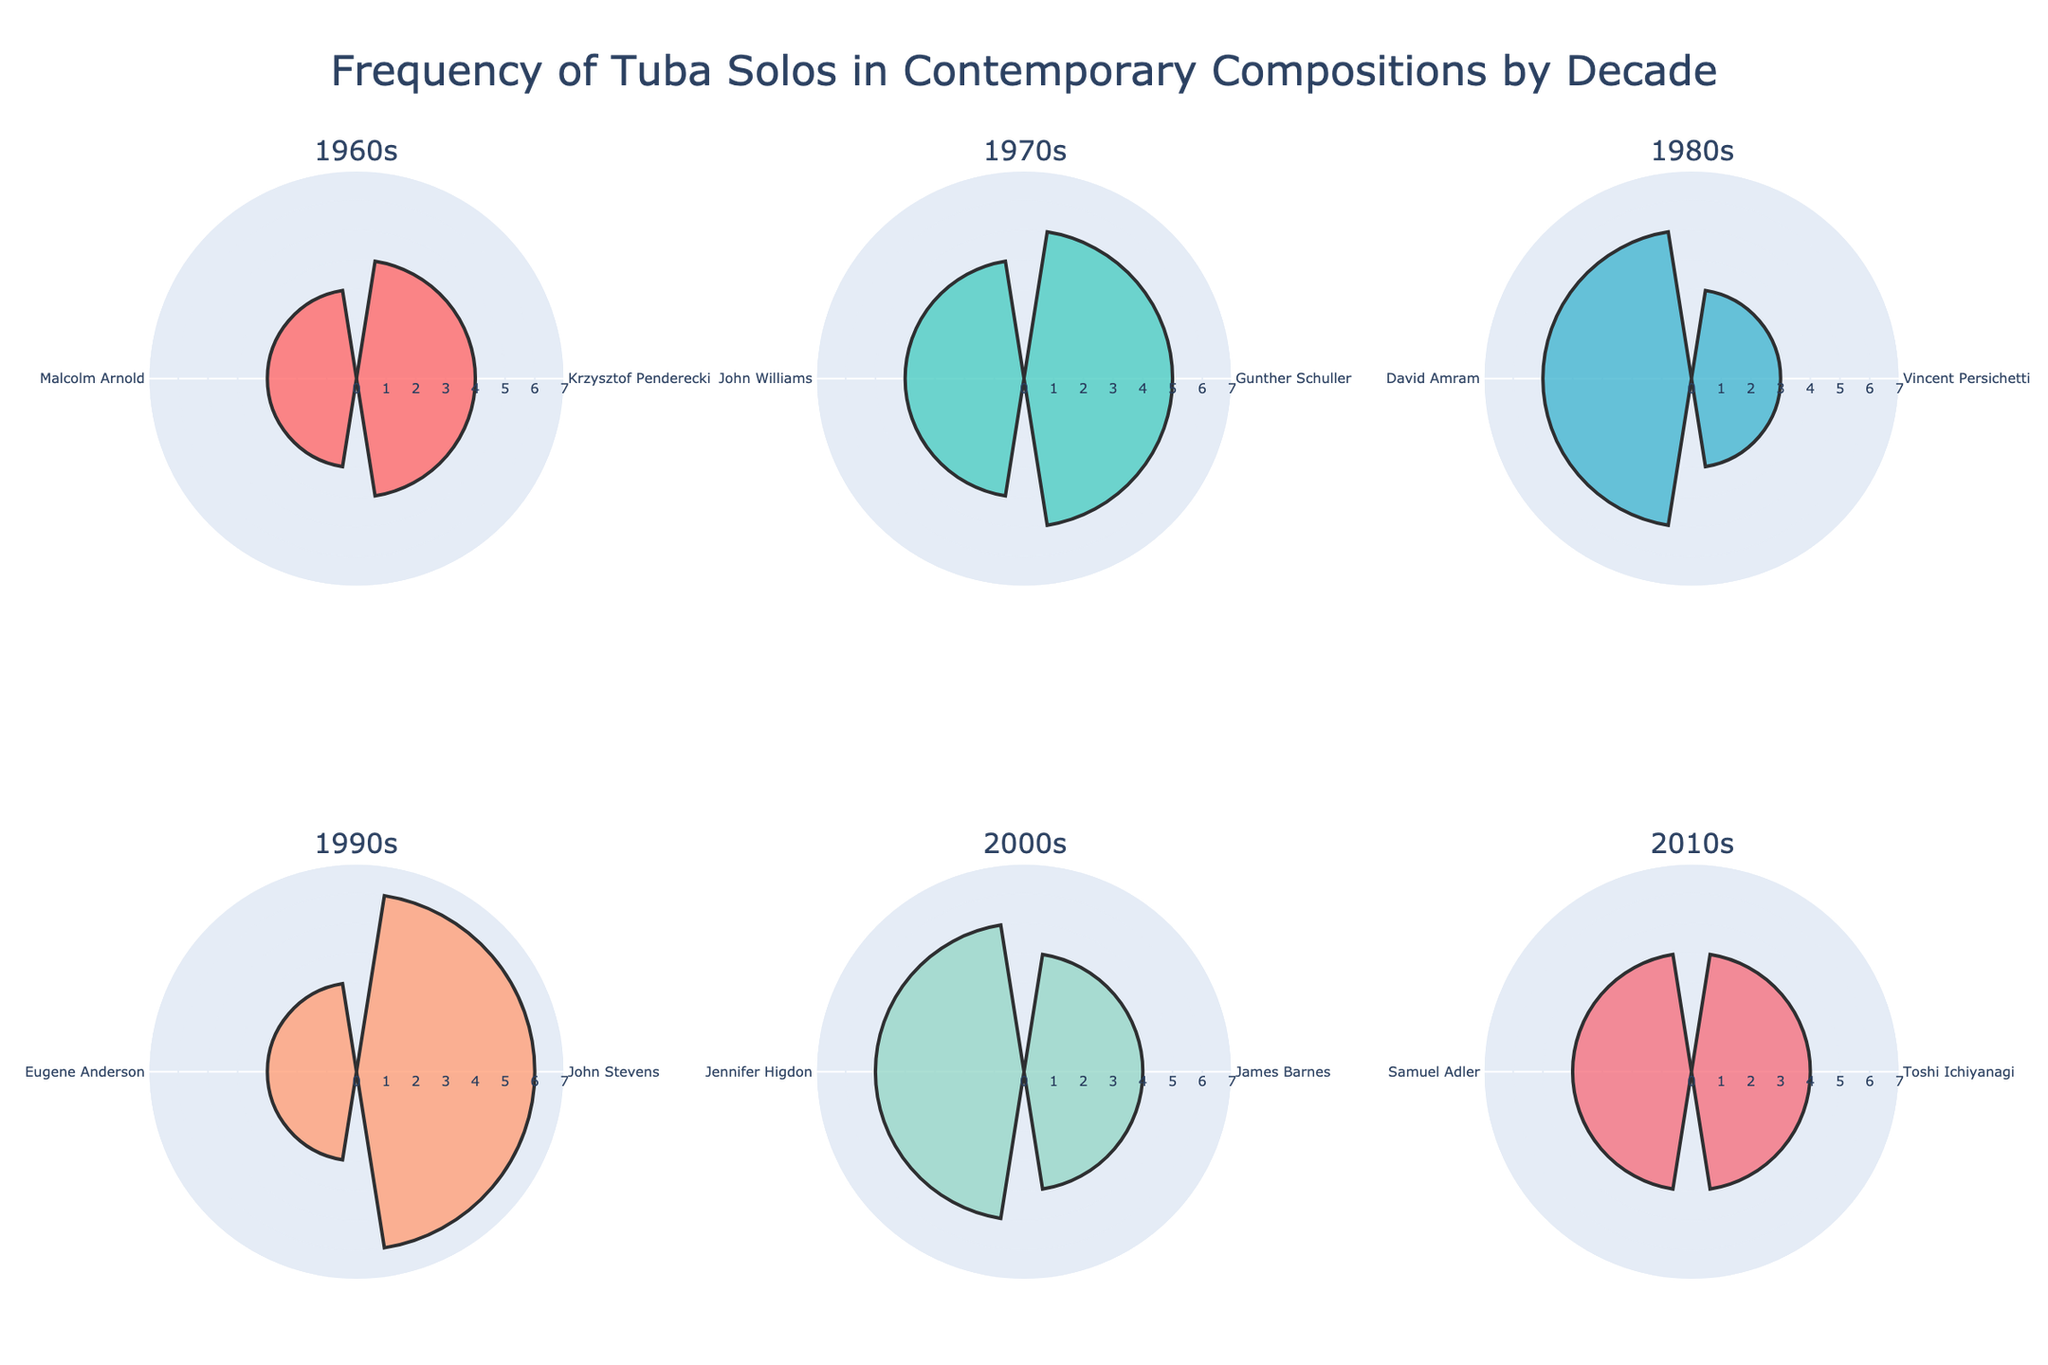What is the title of the figure? The title is usually displayed at the top of the figure. In this case, the title is bold and centered.
Answer: Frequency of Tuba Solos in Contemporary Compositions by Decade Which decade has the highest frequency of tuba solos in one composition? Look at all the degrees in each subplot and identify which subplot has the highest degree value on one of its polar radial bars. The 1990s have a radial value of 6 for John Stevens' "Journey," the highest in all subplots.
Answer: 1990s How many composers are featured in the 1980s subplot? Count the number of distinct sections (theta) in the 1980s subplot. The 1980s subplot has slices for Vincent Persichetti and David Amram, making it a total of two composers.
Answer: 2 What is the average number of tuba solos per composition in the 2000s? Add the number of tuba solos from all compositions in the 2000s and divide by the number of compositions. For the 2000s: (4 + 5) / 2 = 4.5.
Answer: 4.5 Which color is used to represent the 1960s in the chart? Identify the color associated with the 1960s subplot by looking at the visualizations for this decade. The rose chart for the 1960s uses a red shade.
Answer: Red Which decade has the most diverse range of compositions based on the number of tuba solos? Determine which decade has compositions with the most variability in the number of solos. The 1990s range from 3 (Eugene Anderson) to 6 (John Stevens).
Answer: 1990s Compare the number of tuba solos between the 1970s and the 2010s. Which decade has a higher cumulative total? Add the number of tuba solos for all compositions in each decade and compare the totals. For the 1970s: 5 (Gunther Schuller) + 4 (John Williams) = 9. For the 2010s: 4 (Toshi Ichiyanagi) + 4 (Samuel Adler) = 8. Therefore, the 1970s have a higher total.
Answer: 1970s What is the total number of tuba solos in the chart? Sum the number of tuba solos from all the compositions across all decades. 4 + 3 + 5 + 4 + 3 + 5 + 6 + 3 + 4 + 5 + 4 + 4 = 50.
Answer: 50 Which composition in the chart has the least number of tuba solos and in which decade does it appear? Identify the compositions with the smallest radial bar segments and find their corresponding decade. Malcolm Arnold's "Fantasy for Tuba" and Eugene Anderson's "Reflections for Tuba" have the least number (3 solos each) and appear in the 1960s and 1990s, respectively.
Answer: Fantasy for Tuba (1960s) and Reflections for Tuba (1990s) How does the frequency of tuba solos in the 1960s compare to that in the 1980s? Sum the number of tuba solos from all compositions in both decades and compare the totals. For the 1960s: 4 (Krzysztof Penderecki) + 3 (Malcolm Arnold) = 7. For the 1980s: 3 (Vincent Persichetti) + 5 (David Amram) = 8. The 1980s have a higher frequency.
Answer: The 1980s have a higher frequency 